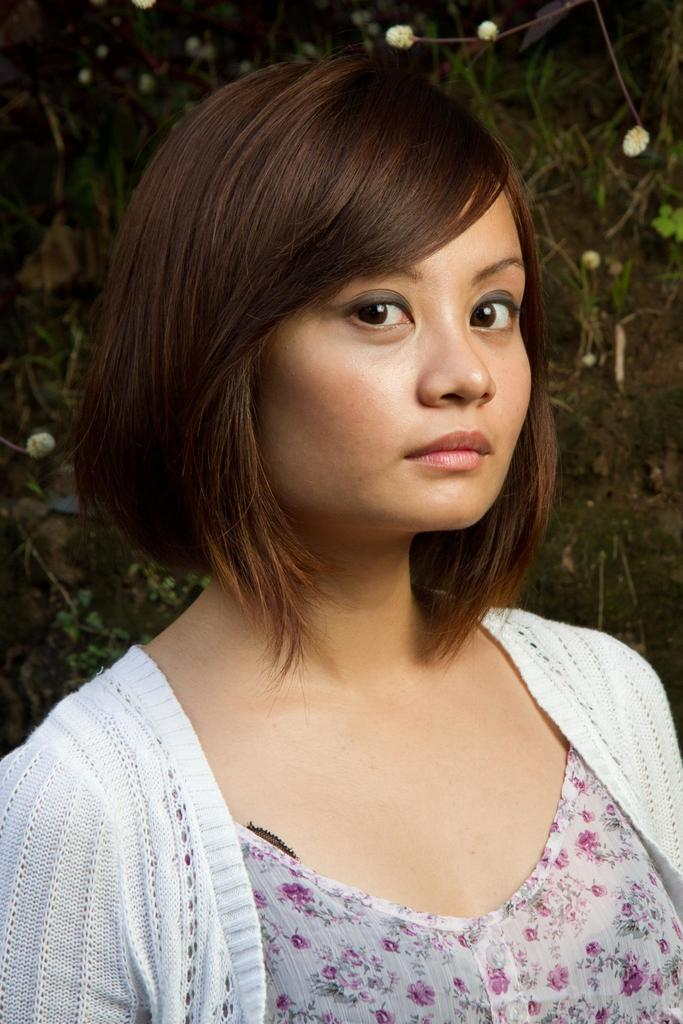What is the main subject of the image? The main subject of the image is a woman. What is the woman wearing in the image? The woman is wearing a white jacket. What can be seen in the background of the image? There are plants visible behind the woman in the image. How many slaves are visible in the image? There are no slaves present in the image; it features a woman wearing a white jacket with plants visible in the background. What type of branch can be seen in the woman's hand in the image? There is no branch visible in the woman's hand in the image. 